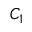<formula> <loc_0><loc_0><loc_500><loc_500>C _ { 1 }</formula> 